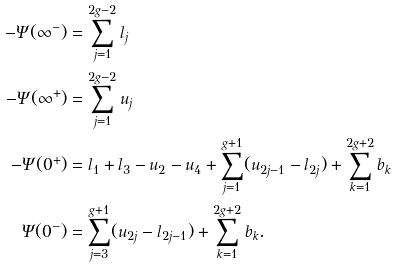<formula> <loc_0><loc_0><loc_500><loc_500>- \Psi ( \infty ^ { - } ) & = \sum _ { j = 1 } ^ { 2 g - 2 } l _ { j } \\ - \Psi ( \infty ^ { + } ) & = \sum _ { j = 1 } ^ { 2 g - 2 } u _ { j } \\ - \Psi ( 0 ^ { + } ) & = l _ { 1 } + l _ { 3 } - u _ { 2 } - u _ { 4 } + \sum _ { j = 1 } ^ { g + 1 } ( u _ { 2 j - 1 } - l _ { 2 j } ) + \sum _ { k = 1 } ^ { 2 g + 2 } b _ { k } \\ \Psi ( 0 ^ { - } ) & = \sum _ { j = 3 } ^ { g + 1 } ( u _ { 2 j } - l _ { 2 j - 1 } ) + \sum _ { k = 1 } ^ { 2 g + 2 } b _ { k } .</formula> 